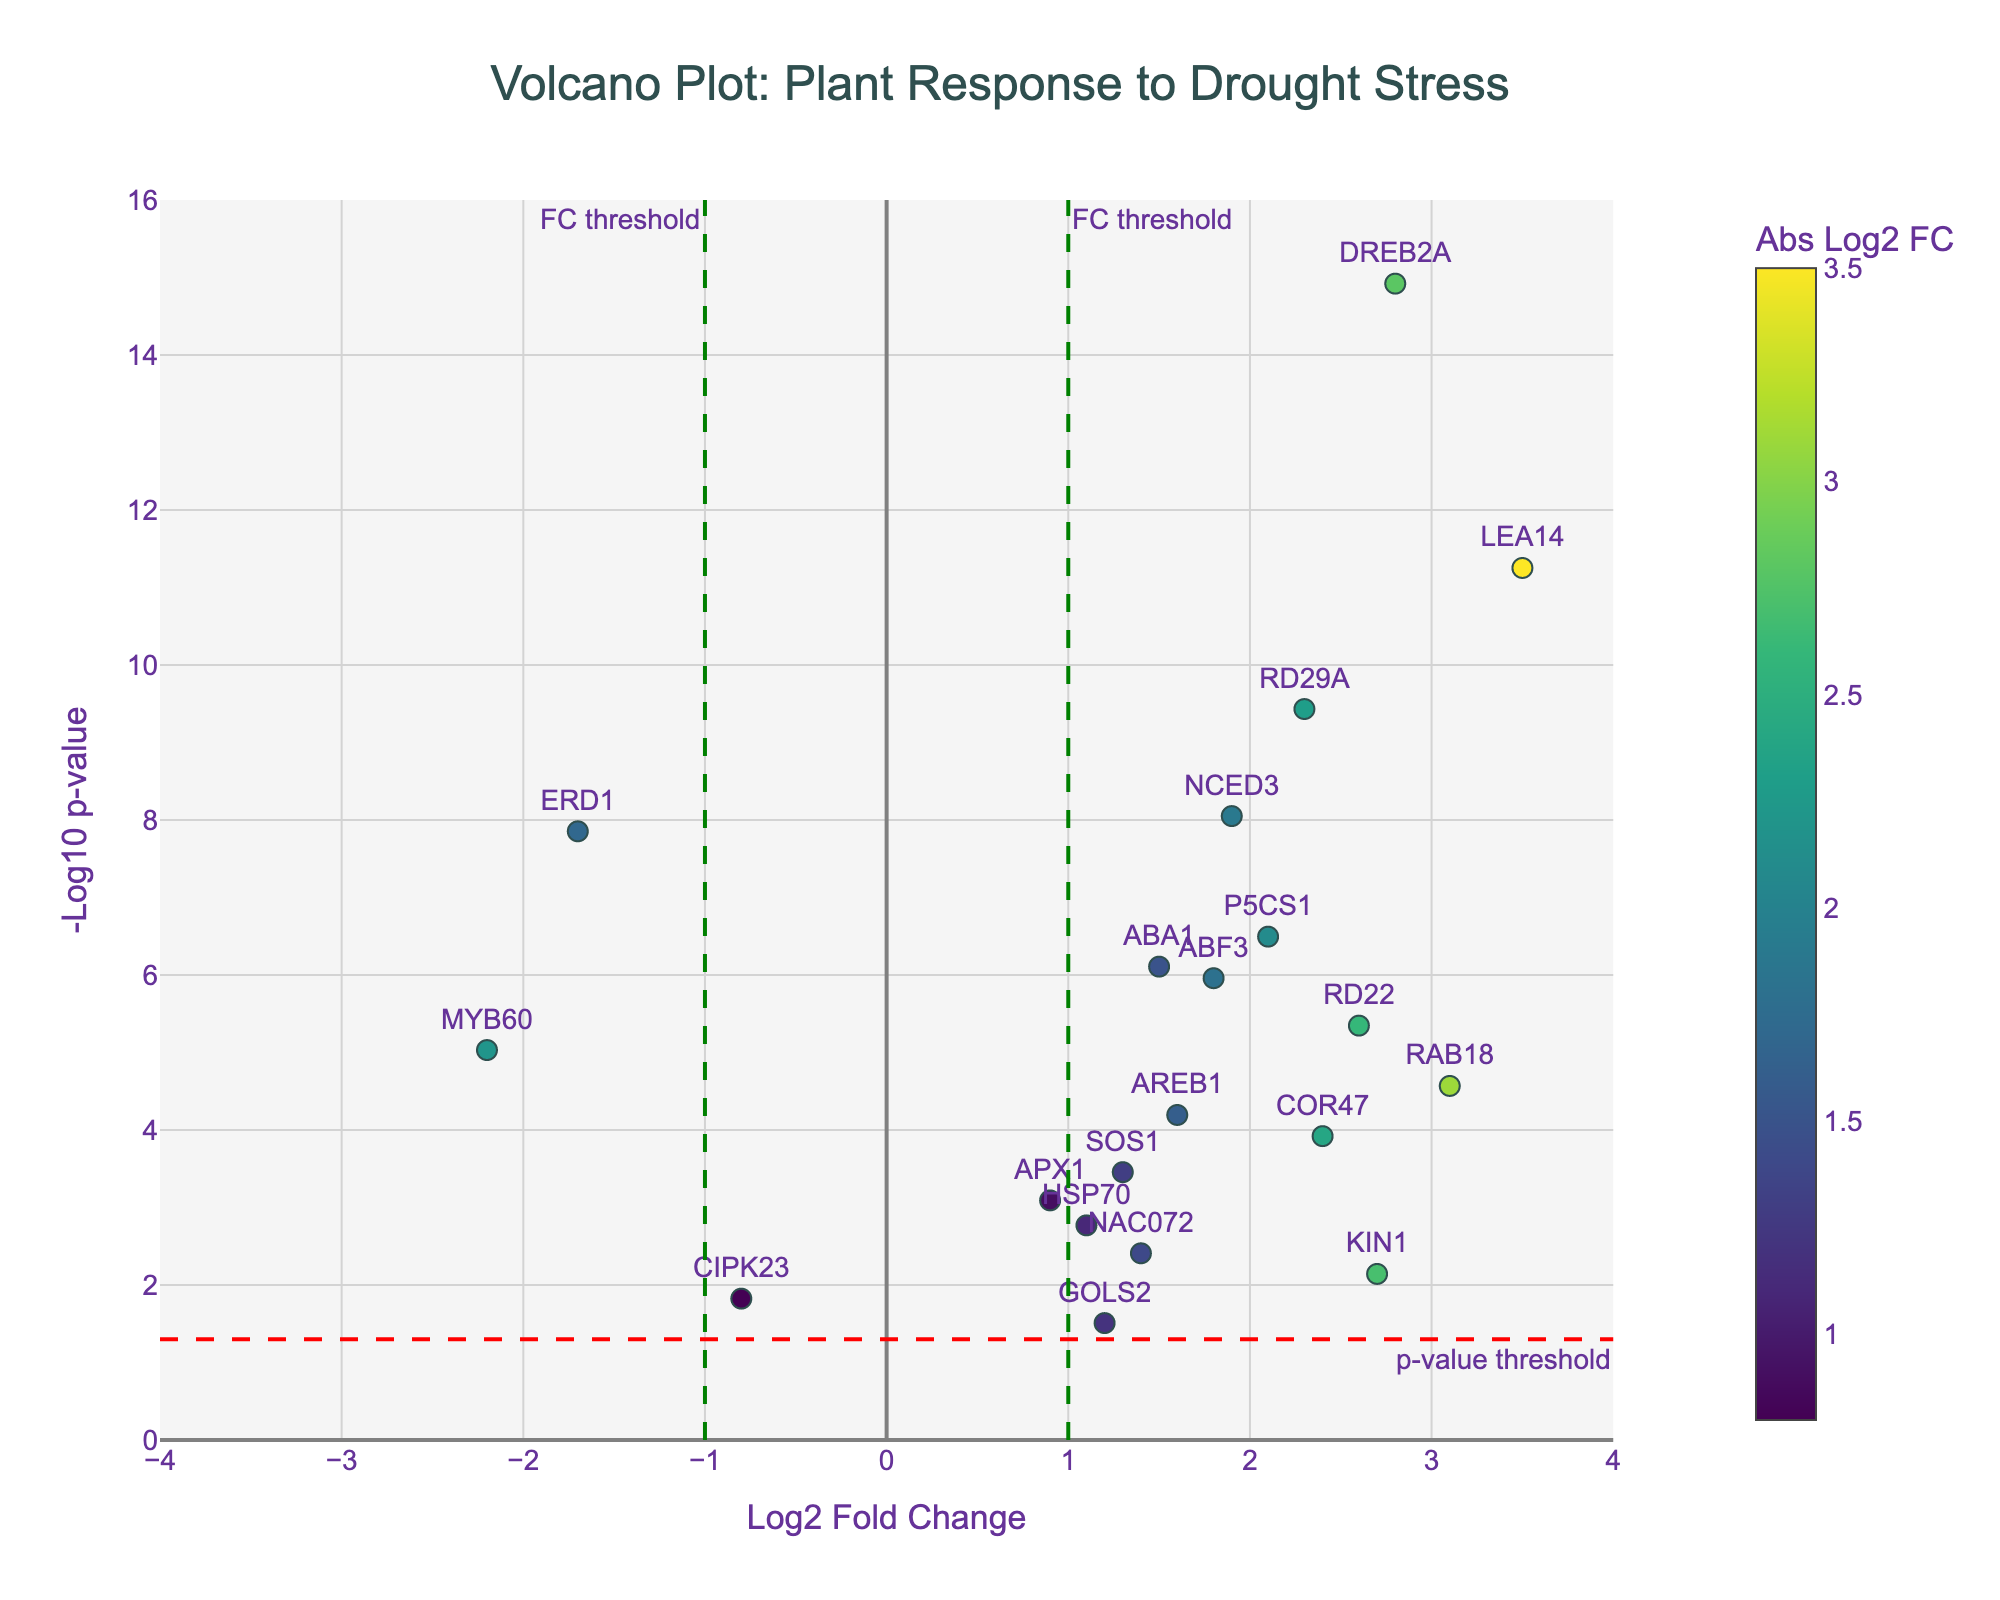what is the title of the plot? The title of the plot is usually found at the top of the figure, typically centered. In this case, the title would be "Volcano Plot: Plant Response to Drought Stress" as specified in the code.
Answer: Volcano Plot: Plant Response to Drought Stress How many genes have a log2 fold change greater than 2.5? To determine the number of genes with a log2 fold change greater than 2.5, look for data points where the x-axis coordinate (log2 fold change) is greater than 2.5. There are 4 genes: "LEA14", "RAB18", "KIN1", and "DREB2A".
Answer: 4 Which gene has the highest -log10 p-value? To find the gene with the highest -log10 p-value, look for the data point that is the highest on the y-axis. The gene "DREB2A" has the highest -log10 p-value.
Answer: DREB2A What color scale is used for the markers? The color scale is usually indicated in the plot's legend or color bar. The color scale used here is "Viridis", ranging from dark blue for low values to yellow for high values.
Answer: Viridis Are there any genes with a negative log2 fold change and a p-value below 0.05? To find genes with a negative log2 fold change and a p-value below 0.05, look for data points to the left of the vertical "FC threshold" line at x = -1 and which are above the horizontal line marking the p-value threshold. The gene "ERD1" fits this description.
Answer: ERD1 How many genes are associated with drought stress response based on their high significance and large effect sizes? To find genes highly associated with drought stress response, look for data points that are beyond both the statistical significance threshold (p < 0.05, or y > -log10(0.05)) and the effect size threshold (log2 fold change > 1 or < -1). There are 14 such genes.
Answer: 14 Which gene has the closest log2 fold change to 2.0, and what is its -log10 p-value? Look around the x-coordinate 2.0. The gene closest is "RD29A" with a log2 fold change of 2.3, and its corresponding -log10 p-value can be observed directly or calculated: -log10(3.7e-10).
Answer: RD29A, 9.43 What is the range of log2 fold change shown on the x-axis? The x-axis range is directly observed from the axis limits defined in the plot: from -4 to 4.
Answer: -4 to 4 Which gene has the most negative log2 fold change and where is it located on the plot? The gene with the most negative log2 fold change is "MYB60". It is located furthest to the left on the plot.
Answer: MYB60, leftmost 